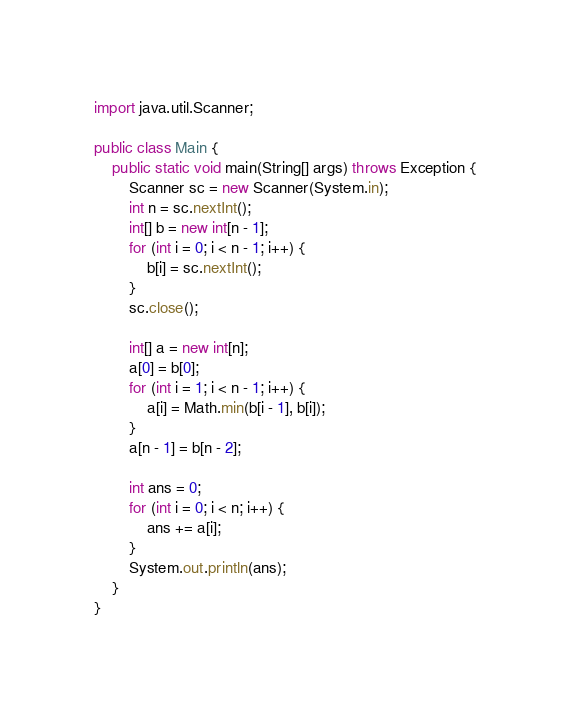<code> <loc_0><loc_0><loc_500><loc_500><_Java_>import java.util.Scanner;

public class Main {
	public static void main(String[] args) throws Exception {
		Scanner sc = new Scanner(System.in);
		int n = sc.nextInt();
		int[] b = new int[n - 1];
		for (int i = 0; i < n - 1; i++) {
			b[i] = sc.nextInt();
		}
		sc.close();

		int[] a = new int[n];
		a[0] = b[0];
		for (int i = 1; i < n - 1; i++) {
			a[i] = Math.min(b[i - 1], b[i]);
		}
		a[n - 1] = b[n - 2];

		int ans = 0;
		for (int i = 0; i < n; i++) {
			ans += a[i];
		}
		System.out.println(ans);
	}
}
</code> 